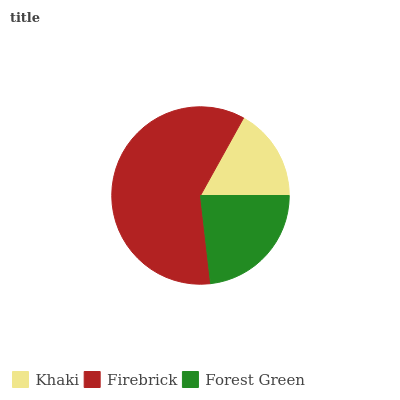Is Khaki the minimum?
Answer yes or no. Yes. Is Firebrick the maximum?
Answer yes or no. Yes. Is Forest Green the minimum?
Answer yes or no. No. Is Forest Green the maximum?
Answer yes or no. No. Is Firebrick greater than Forest Green?
Answer yes or no. Yes. Is Forest Green less than Firebrick?
Answer yes or no. Yes. Is Forest Green greater than Firebrick?
Answer yes or no. No. Is Firebrick less than Forest Green?
Answer yes or no. No. Is Forest Green the high median?
Answer yes or no. Yes. Is Forest Green the low median?
Answer yes or no. Yes. Is Firebrick the high median?
Answer yes or no. No. Is Khaki the low median?
Answer yes or no. No. 